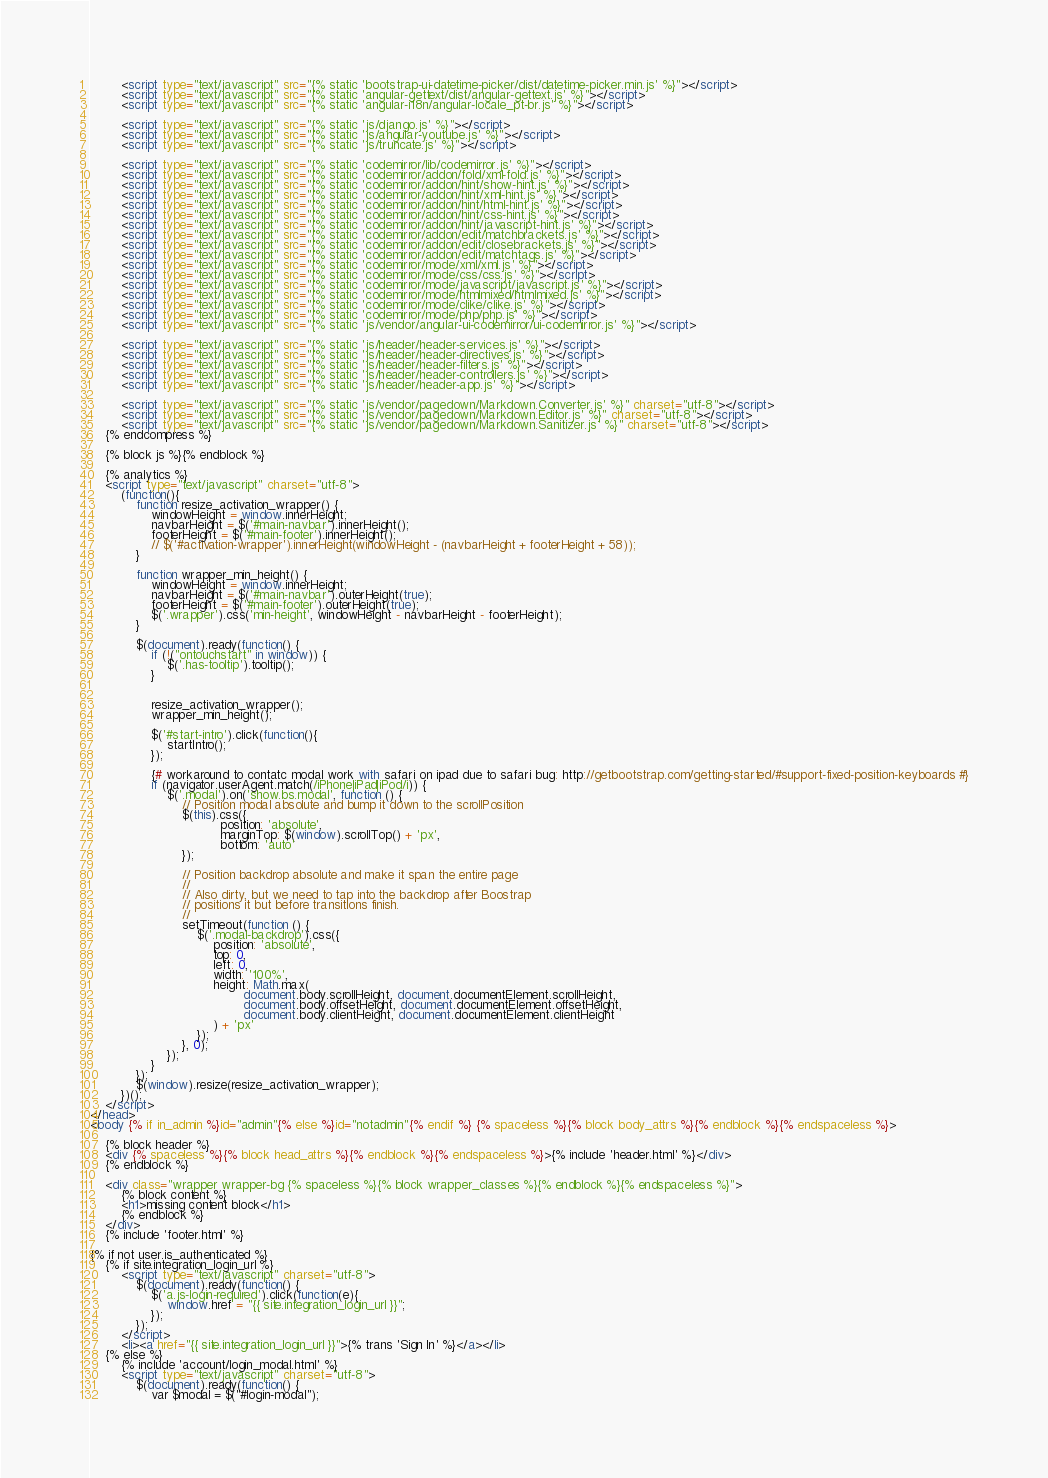<code> <loc_0><loc_0><loc_500><loc_500><_HTML_>        <script type="text/javascript" src="{% static 'bootstrap-ui-datetime-picker/dist/datetime-picker.min.js' %}"></script>
        <script type="text/javascript" src="{% static 'angular-gettext/dist/angular-gettext.js' %}"></script>
        <script type="text/javascript" src="{% static 'angular-i18n/angular-locale_pt-br.js' %}"></script>

        <script type="text/javascript" src="{% static 'js/django.js' %}"></script>
        <script type="text/javascript" src="{% static 'js/angular-youtube.js' %}"></script>
        <script type="text/javascript" src="{% static 'js/truncate.js' %}"></script>

        <script type="text/javascript" src="{% static 'codemirror/lib/codemirror.js' %}"></script>
        <script type="text/javascript" src="{% static 'codemirror/addon/fold/xml-fold.js' %}"></script>
        <script type="text/javascript" src="{% static 'codemirror/addon/hint/show-hint.js' %}"></script>
        <script type="text/javascript" src="{% static 'codemirror/addon/hint/xml-hint.js' %}"></script>
        <script type="text/javascript" src="{% static 'codemirror/addon/hint/html-hint.js' %}"></script>
        <script type="text/javascript" src="{% static 'codemirror/addon/hint/css-hint.js' %}"></script>
        <script type="text/javascript" src="{% static 'codemirror/addon/hint/javascript-hint.js' %}"></script>
        <script type="text/javascript" src="{% static 'codemirror/addon/edit/matchbrackets.js' %}"></script>
        <script type="text/javascript" src="{% static 'codemirror/addon/edit/closebrackets.js' %}"></script>
        <script type="text/javascript" src="{% static 'codemirror/addon/edit/matchtags.js' %}"></script>
        <script type="text/javascript" src="{% static 'codemirror/mode/xml/xml.js' %}"></script>
        <script type="text/javascript" src="{% static 'codemirror/mode/css/css.js' %}"></script>
        <script type="text/javascript" src="{% static 'codemirror/mode/javascript/javascript.js' %}"></script>
        <script type="text/javascript" src="{% static 'codemirror/mode/htmlmixed/htmlmixed.js' %}"></script>
        <script type="text/javascript" src="{% static 'codemirror/mode/clike/clike.js' %}"></script>
        <script type="text/javascript" src="{% static 'codemirror/mode/php/php.js' %}"></script>
        <script type="text/javascript" src="{% static 'js/vendor/angular-ui-codemirror/ui-codemirror.js' %}"></script>

        <script type="text/javascript" src="{% static 'js/header/header-services.js' %}"></script>
        <script type="text/javascript" src="{% static 'js/header/header-directives.js' %}"></script>
        <script type="text/javascript" src="{% static 'js/header/header-filters.js' %}"></script>
        <script type="text/javascript" src="{% static 'js/header/header-controllers.js' %}"></script>
        <script type="text/javascript" src="{% static 'js/header/header-app.js' %}"></script>

        <script type="text/javascript" src="{% static 'js/vendor/pagedown/Markdown.Converter.js' %}" charset="utf-8"></script>
        <script type="text/javascript" src="{% static 'js/vendor/pagedown/Markdown.Editor.js' %}" charset="utf-8"></script>
        <script type="text/javascript" src="{% static 'js/vendor/pagedown/Markdown.Sanitizer.js' %}" charset="utf-8"></script>
    {% endcompress %}

    {% block js %}{% endblock %}

    {% analytics %}
    <script type="text/javascript" charset="utf-8">
        (function(){
            function resize_activation_wrapper() {
                windowHeight = window.innerHeight;
                navbarHeight = $('#main-navbar').innerHeight();
                footerHeight = $('#main-footer').innerHeight();
                // $('#activation-wrapper').innerHeight(windowHeight - (navbarHeight + footerHeight + 58));
            }

            function wrapper_min_height() {
                windowHeight = window.innerHeight;
                navbarHeight = $('#main-navbar').outerHeight(true);
                footerHeight = $('#main-footer').outerHeight(true);
                $('.wrapper').css('min-height', windowHeight - navbarHeight - footerHeight);
            }

            $(document).ready(function() {
                if (!("ontouchstart" in window)) {
                    $('.has-tooltip').tooltip();
                }


                resize_activation_wrapper();
                wrapper_min_height();

                $('#start-intro').click(function(){
                    startIntro();
                });

				{# workaround to contatc modal work with safari on ipad due to safari bug: http://getbootstrap.com/getting-started/#support-fixed-position-keyboards #}
				if (navigator.userAgent.match(/iPhone|iPad|iPod/i)) {
					$('.modal').on('show.bs.modal', function () {
						// Position modal absolute and bump it down to the scrollPosition
						$(this).css({
								  position: 'absolute',
								  marginTop: $(window).scrollTop() + 'px',
								  bottom: 'auto'
						});

						// Position backdrop absolute and make it span the entire page
						//
						// Also dirty, but we need to tap into the backdrop after Boostrap
						// positions it but before transitions finish.
						//
						setTimeout(function () {
							$('.modal-backdrop').css({
								position: 'absolute',
								top: 0,
								left: 0,
								width: '100%',
								height: Math.max(
										document.body.scrollHeight, document.documentElement.scrollHeight,
										document.body.offsetHeight, document.documentElement.offsetHeight,
										document.body.clientHeight, document.documentElement.clientHeight
								) + 'px'
							});
						}, 0);
					});
				}
            });
            $(window).resize(resize_activation_wrapper);
        })();
    </script>
</head>
<body {% if in_admin %}id="admin"{% else %}id="notadmin"{% endif %} {% spaceless %}{% block body_attrs %}{% endblock %}{% endspaceless %}>

    {% block header %}
    <div {% spaceless %}{% block head_attrs %}{% endblock %}{% endspaceless %}>{% include 'header.html' %}</div>
    {% endblock %}

    <div class="wrapper wrapper-bg {% spaceless %}{% block wrapper_classes %}{% endblock %}{% endspaceless %}">
        {% block content %}
        <h1>missing content block</h1>
        {% endblock %}
    </div>
    {% include 'footer.html' %}

{% if not user.is_authenticated %}
    {% if site.integration_login_url %}
        <script type="text/javascript" charset="utf-8">
            $(document).ready(function() {
                $('a.js-login-required').click(function(e){
                    window.href = "{{ site.integration_login_url }}";
                });
            });
        </script>
        <li><a href="{{ site.integration_login_url }}">{% trans 'Sign In' %}</a></li>
    {% else %}
        {% include 'account/login_modal.html' %}
        <script type="text/javascript" charset="utf-8">
            $(document).ready(function() {
                var $modal = $("#login-modal");</code> 